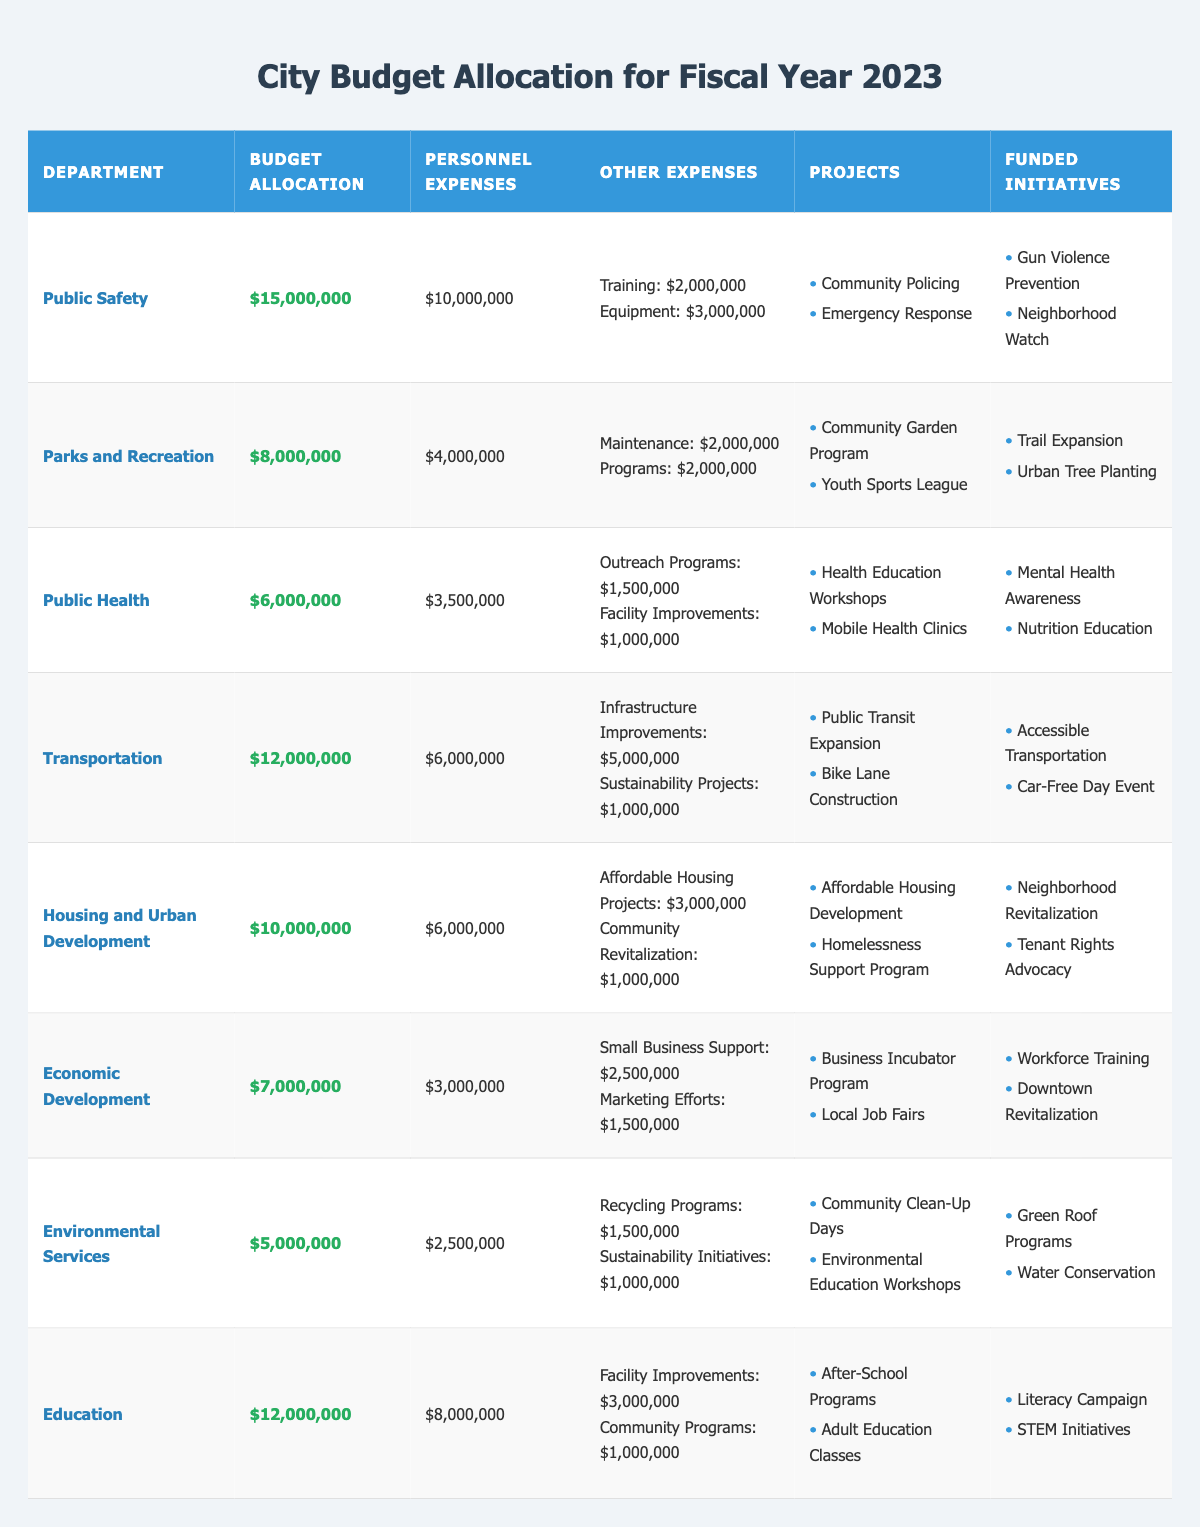What is the budget allocation for the Public Health department? The budget allocation for the Public Health department is clearly listed in the table as $6,000,000.
Answer: $6,000,000 Which department has the highest budget allocation? By comparing the budget allocations of each department, Public Safety has the highest budget allocation of $15,000,000.
Answer: Public Safety How much is allocated for personnel expenses in Transportation? The table indicates that the personnel expenses for the Transportation department are $6,000,000.
Answer: $6,000,000 What is the total budget allocation for Parks and Recreation and Economic Development? The budget allocation for Parks and Recreation is $8,000,000 and for Economic Development is $7,000,000. Adding these gives $8,000,000 + $7,000,000 = $15,000,000.
Answer: $15,000,000 Does the Public Safety department have funding for Gun Violence Prevention? The table shows that Gun Violence Prevention is listed as one of the funded initiatives for the Public Safety department.
Answer: Yes Which two departments have the same budget allocation? The Education and Transportation departments both have a budget allocation of $12,000,000.
Answer: Education and Transportation What is the total personnel expenses for all departments? Summing the personnel expenses for all departments gives $10,000,000 + $4,000,000 + $3,500,000 + $6,000,000 + $6,000,000 + $3,000,000 + $2,500,000 + $8,000,000 = $43,000,000.
Answer: $43,000,000 How much funding is allocated for sustainability projects in Transportation? The table lists the sustainability projects expenses for the Transportation department as $1,000,000.
Answer: $1,000,000 Are any departments allocated less than $6,000,000? Upon examination, Environmental Services is allocated $5,000,000, which is less than $6,000,000.
Answer: Yes What is the combined budget allocation for Education and Public Health departments? Adding the budget allocations, Education has $12,000,000 and Public Health has $6,000,000; therefore, $12,000,000 + $6,000,000 = $18,000,000.
Answer: $18,000,000 What percentage of the total budget is allocated to Housing and Urban Development? First, the total budget is calculated by summing all allocations: $15,000,000 + $8,000,000 + $6,000,000 + $12,000,000 + $10,000,000 + $7,000,000 + $5,000,000 + $12,000,000 = $75,000,000. Then, the allocation for Housing and Urban Development, which is $10,000,000, is divided by the total budget: ($10,000,000 / $75,000,000) * 100 = 13.33%.
Answer: 13.33% 